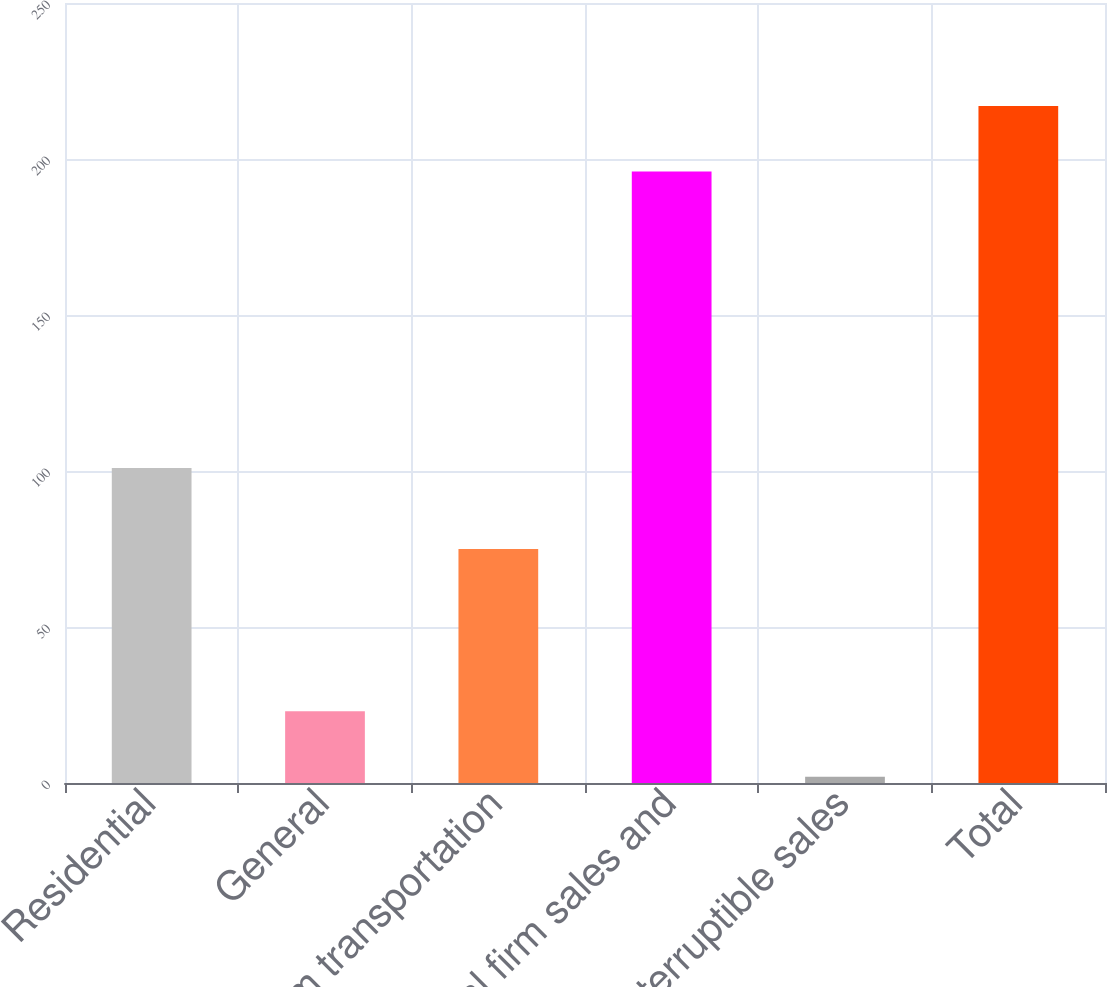Convert chart to OTSL. <chart><loc_0><loc_0><loc_500><loc_500><bar_chart><fcel>Residential<fcel>General<fcel>Firm transportation<fcel>Total firm sales and<fcel>Interruptible sales<fcel>Total<nl><fcel>101<fcel>23<fcel>75<fcel>196<fcel>2<fcel>217<nl></chart> 